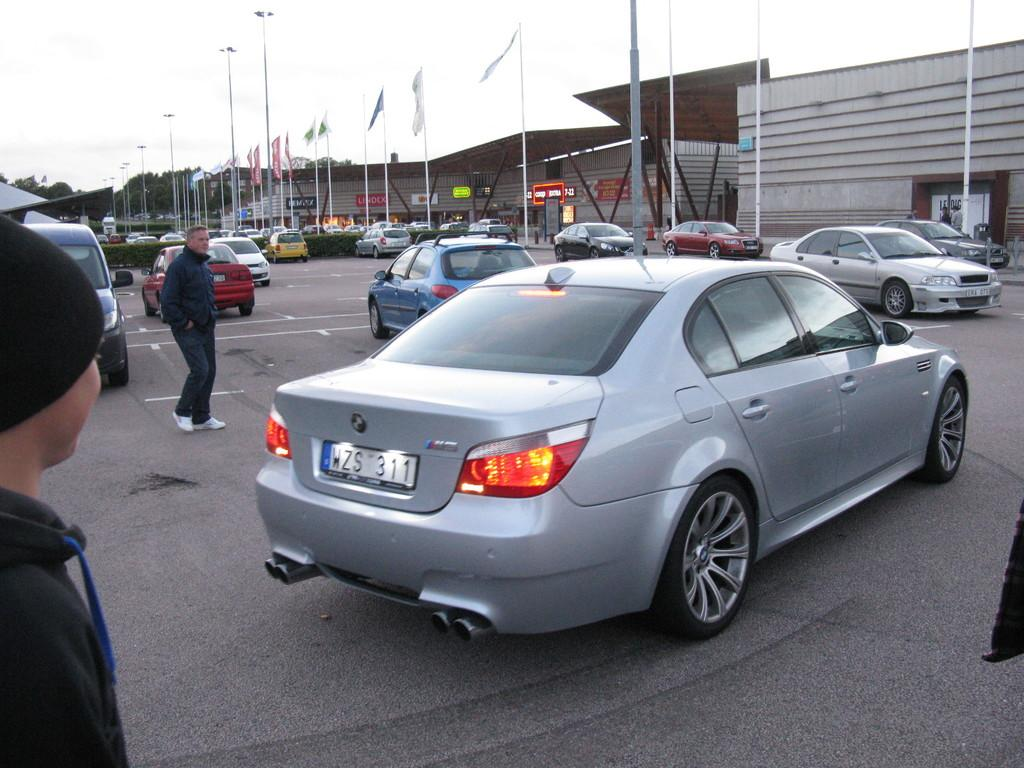<image>
Give a short and clear explanation of the subsequent image. a silver car in a parking lot with license plate WZS 311 